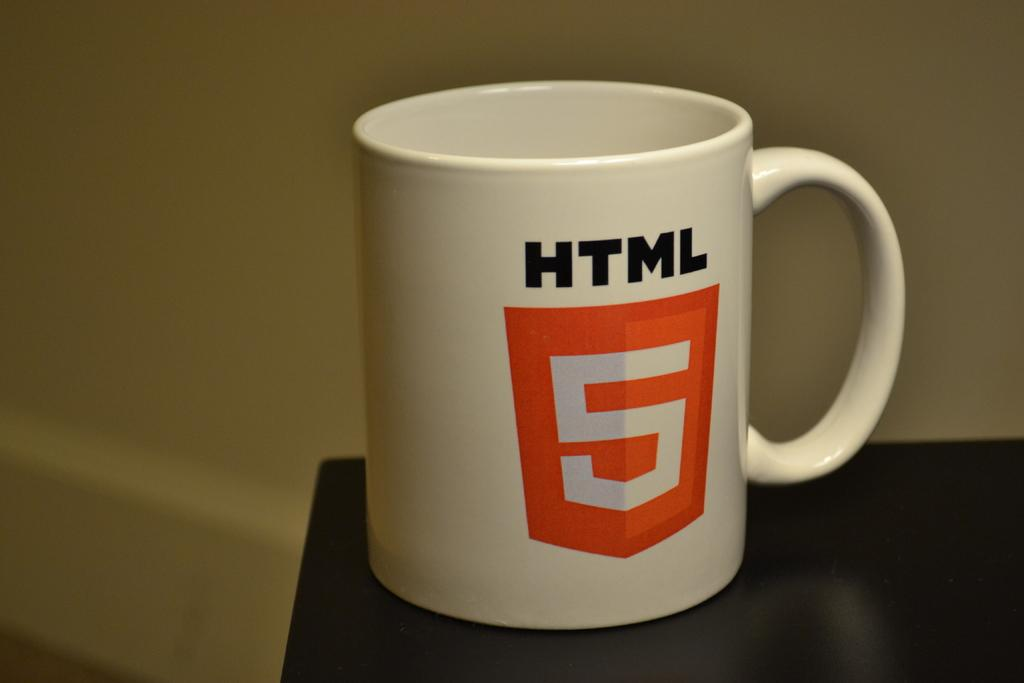Provide a one-sentence caption for the provided image. A white cup with black font reading HTML and a orange shield with a number 5. 